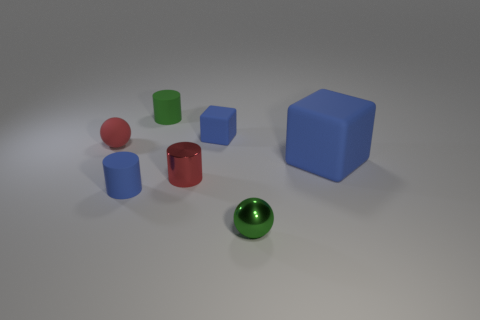Add 2 red matte spheres. How many objects exist? 9 Subtract all blocks. How many objects are left? 5 Add 7 small blue blocks. How many small blue blocks are left? 8 Add 2 large blue rubber things. How many large blue rubber things exist? 3 Subtract 0 yellow balls. How many objects are left? 7 Subtract all tiny blue objects. Subtract all tiny metal spheres. How many objects are left? 4 